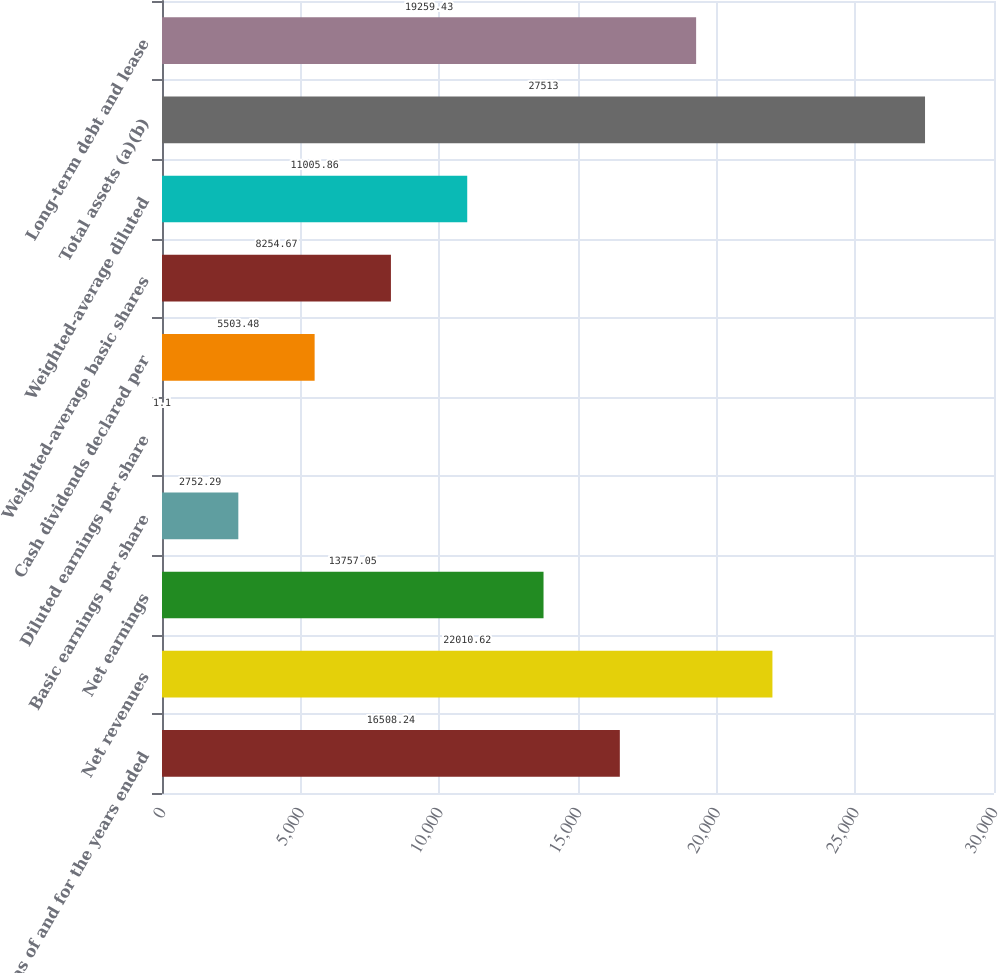Convert chart. <chart><loc_0><loc_0><loc_500><loc_500><bar_chart><fcel>as of and for the years ended<fcel>Net revenues<fcel>Net earnings<fcel>Basic earnings per share<fcel>Diluted earnings per share<fcel>Cash dividends declared per<fcel>Weighted-average basic shares<fcel>Weighted-average diluted<fcel>Total assets (a)(b)<fcel>Long-term debt and lease<nl><fcel>16508.2<fcel>22010.6<fcel>13757<fcel>2752.29<fcel>1.1<fcel>5503.48<fcel>8254.67<fcel>11005.9<fcel>27513<fcel>19259.4<nl></chart> 